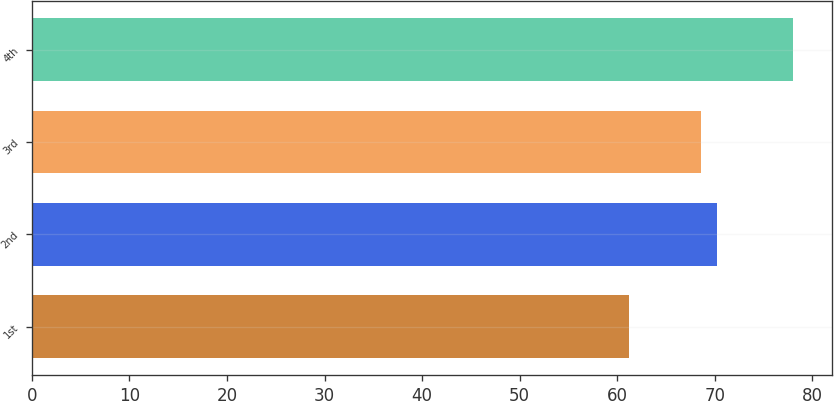Convert chart. <chart><loc_0><loc_0><loc_500><loc_500><bar_chart><fcel>1st<fcel>2nd<fcel>3rd<fcel>4th<nl><fcel>61.25<fcel>70.27<fcel>68.59<fcel>78.06<nl></chart> 